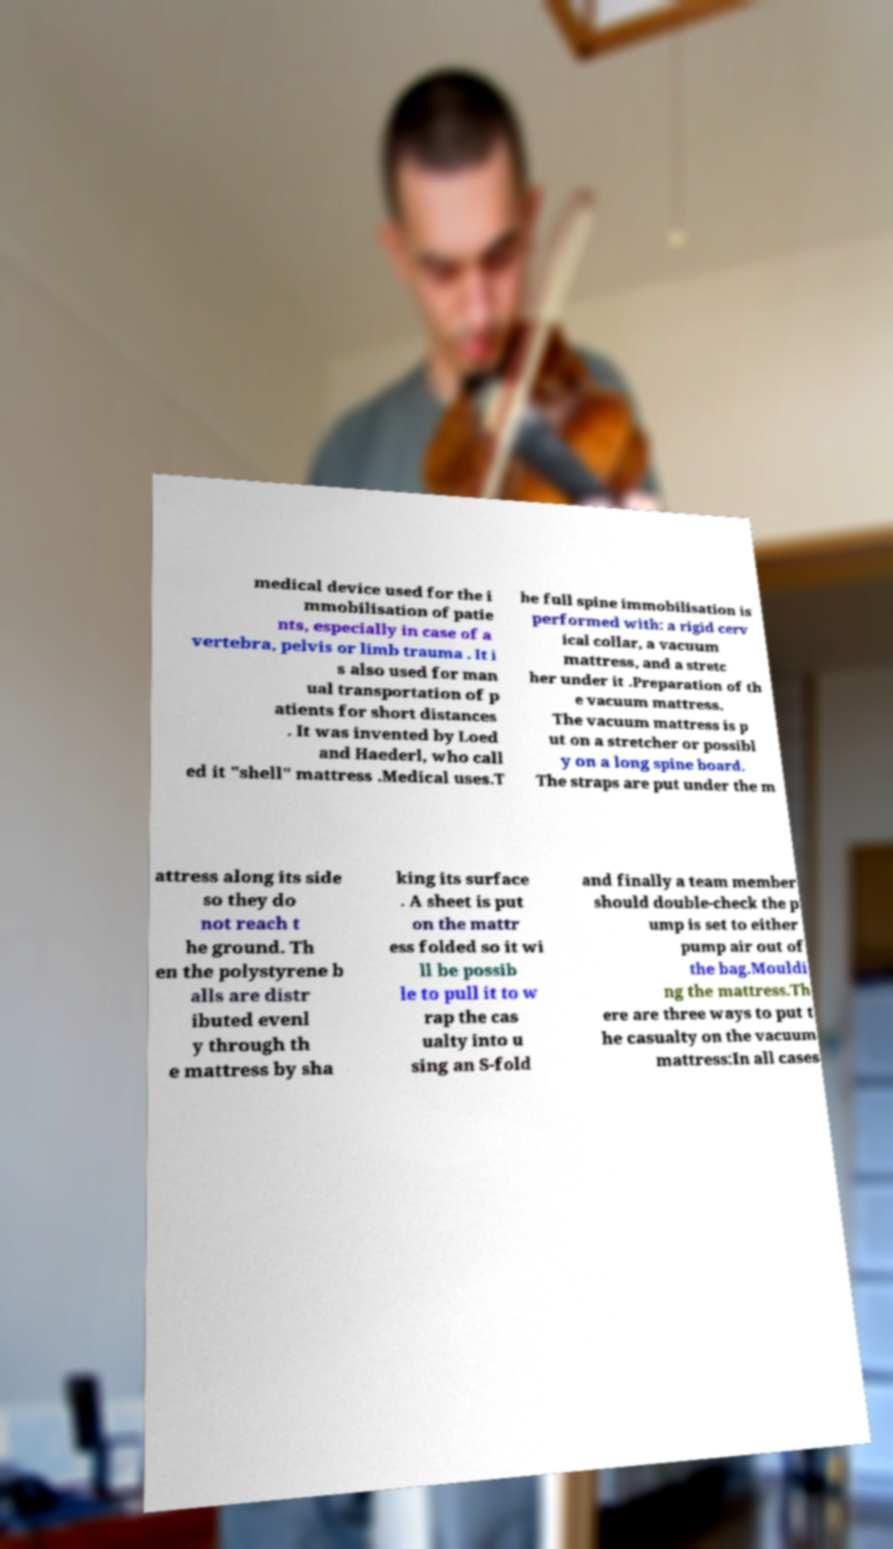What messages or text are displayed in this image? I need them in a readable, typed format. medical device used for the i mmobilisation of patie nts, especially in case of a vertebra, pelvis or limb trauma . It i s also used for man ual transportation of p atients for short distances . It was invented by Loed and Haederl, who call ed it "shell" mattress .Medical uses.T he full spine immobilisation is performed with: a rigid cerv ical collar, a vacuum mattress, and a stretc her under it .Preparation of th e vacuum mattress. The vacuum mattress is p ut on a stretcher or possibl y on a long spine board. The straps are put under the m attress along its side so they do not reach t he ground. Th en the polystyrene b alls are distr ibuted evenl y through th e mattress by sha king its surface . A sheet is put on the mattr ess folded so it wi ll be possib le to pull it to w rap the cas ualty into u sing an S-fold and finally a team member should double-check the p ump is set to either pump air out of the bag.Mouldi ng the mattress.Th ere are three ways to put t he casualty on the vacuum mattress:In all cases 